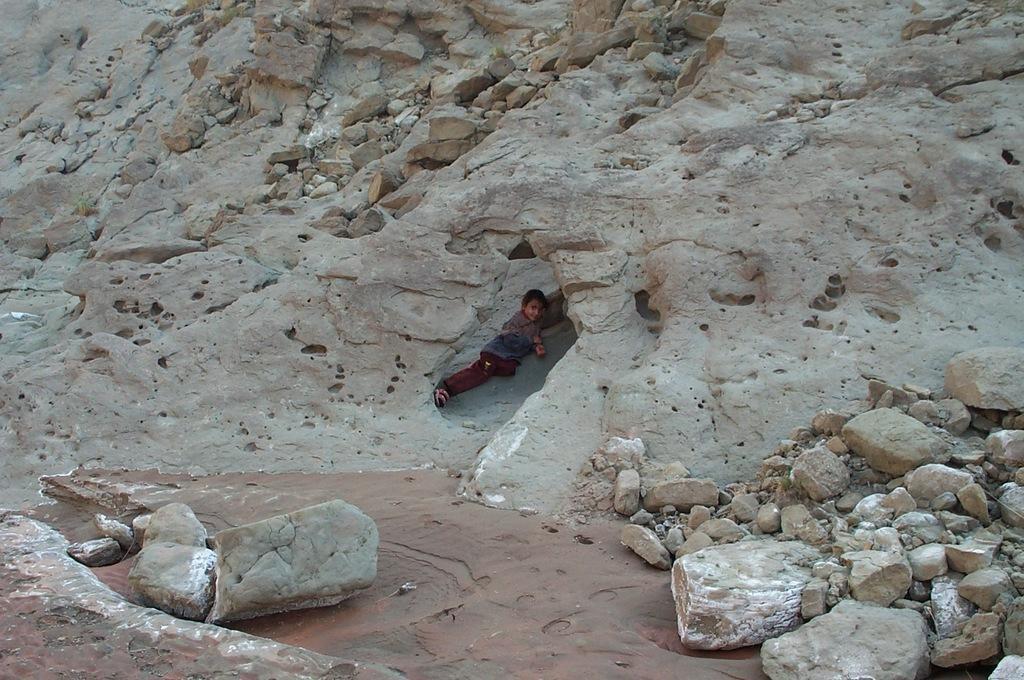How would you summarize this image in a sentence or two? In this image we can see rocks. Middle of the image there is a person. 